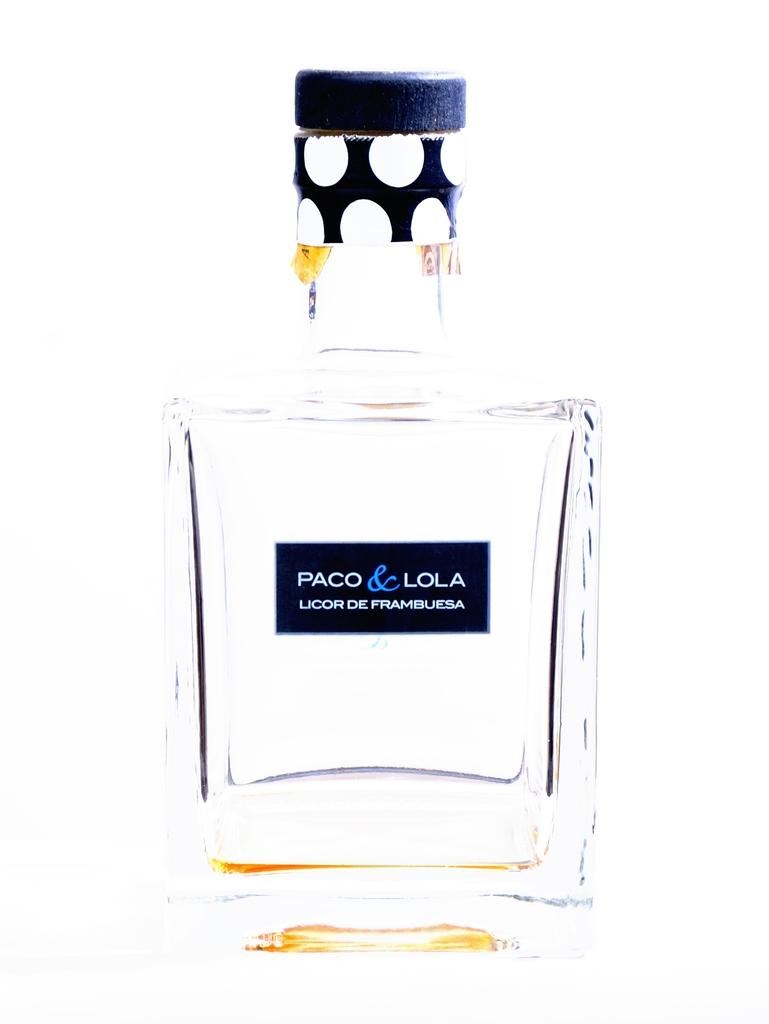Provide a one-sentence caption for the provided image. A translucent bottle of Paco & Lola liquor. 